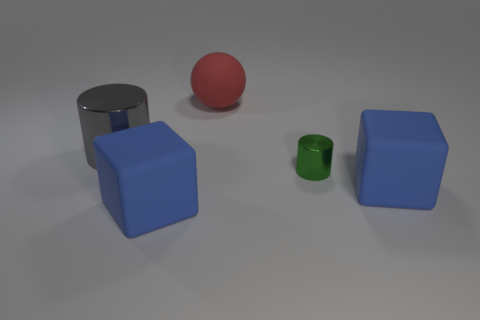Which objects in this image have similar colours? The two blue cubes have similar colors, exhibiting shades of blue. 